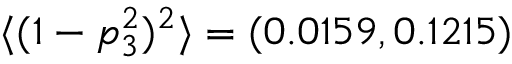<formula> <loc_0><loc_0><loc_500><loc_500>\langle ( 1 - p _ { 3 } ^ { 2 } ) ^ { 2 } \rangle = ( 0 . 0 1 5 9 , 0 . 1 2 1 5 )</formula> 